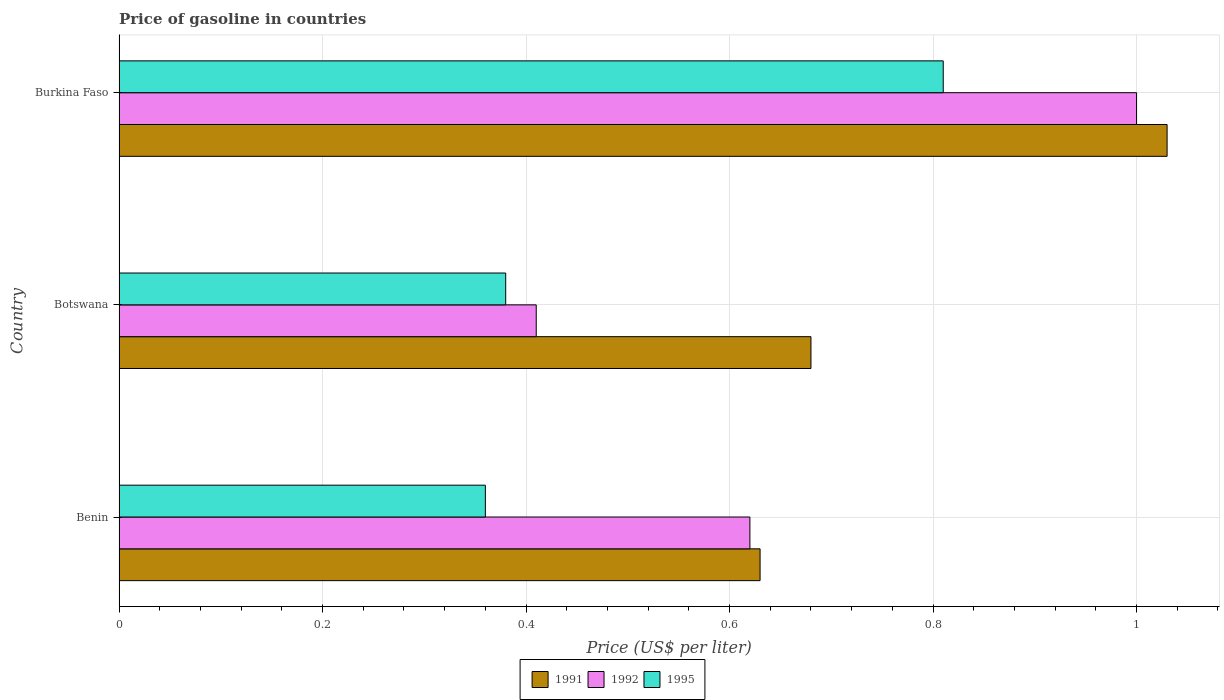How many different coloured bars are there?
Offer a terse response. 3. How many groups of bars are there?
Offer a very short reply. 3. Are the number of bars on each tick of the Y-axis equal?
Your response must be concise. Yes. How many bars are there on the 2nd tick from the bottom?
Offer a very short reply. 3. What is the label of the 1st group of bars from the top?
Provide a succinct answer. Burkina Faso. In how many cases, is the number of bars for a given country not equal to the number of legend labels?
Make the answer very short. 0. What is the price of gasoline in 1992 in Burkina Faso?
Offer a very short reply. 1. Across all countries, what is the maximum price of gasoline in 1995?
Keep it short and to the point. 0.81. Across all countries, what is the minimum price of gasoline in 1995?
Offer a terse response. 0.36. In which country was the price of gasoline in 1995 maximum?
Your answer should be very brief. Burkina Faso. In which country was the price of gasoline in 1991 minimum?
Ensure brevity in your answer.  Benin. What is the total price of gasoline in 1991 in the graph?
Ensure brevity in your answer.  2.34. What is the difference between the price of gasoline in 1992 in Benin and that in Botswana?
Give a very brief answer. 0.21. What is the difference between the price of gasoline in 1991 in Burkina Faso and the price of gasoline in 1992 in Benin?
Give a very brief answer. 0.41. What is the average price of gasoline in 1995 per country?
Provide a short and direct response. 0.52. What is the difference between the price of gasoline in 1991 and price of gasoline in 1992 in Botswana?
Offer a terse response. 0.27. In how many countries, is the price of gasoline in 1991 greater than 0.88 US$?
Your answer should be compact. 1. What is the ratio of the price of gasoline in 1995 in Benin to that in Burkina Faso?
Ensure brevity in your answer.  0.44. Is the price of gasoline in 1995 in Botswana less than that in Burkina Faso?
Offer a very short reply. Yes. What is the difference between the highest and the second highest price of gasoline in 1991?
Provide a succinct answer. 0.35. What is the difference between the highest and the lowest price of gasoline in 1992?
Offer a terse response. 0.59. In how many countries, is the price of gasoline in 1995 greater than the average price of gasoline in 1995 taken over all countries?
Provide a succinct answer. 1. What does the 2nd bar from the top in Benin represents?
Provide a short and direct response. 1992. How many bars are there?
Provide a succinct answer. 9. How many countries are there in the graph?
Your answer should be compact. 3. Does the graph contain any zero values?
Your response must be concise. No. Where does the legend appear in the graph?
Ensure brevity in your answer.  Bottom center. How are the legend labels stacked?
Keep it short and to the point. Horizontal. What is the title of the graph?
Your answer should be very brief. Price of gasoline in countries. Does "2004" appear as one of the legend labels in the graph?
Offer a very short reply. No. What is the label or title of the X-axis?
Offer a terse response. Price (US$ per liter). What is the label or title of the Y-axis?
Offer a very short reply. Country. What is the Price (US$ per liter) of 1991 in Benin?
Provide a short and direct response. 0.63. What is the Price (US$ per liter) of 1992 in Benin?
Offer a terse response. 0.62. What is the Price (US$ per liter) in 1995 in Benin?
Offer a very short reply. 0.36. What is the Price (US$ per liter) in 1991 in Botswana?
Offer a very short reply. 0.68. What is the Price (US$ per liter) of 1992 in Botswana?
Your response must be concise. 0.41. What is the Price (US$ per liter) of 1995 in Botswana?
Keep it short and to the point. 0.38. What is the Price (US$ per liter) in 1991 in Burkina Faso?
Provide a short and direct response. 1.03. What is the Price (US$ per liter) of 1992 in Burkina Faso?
Your response must be concise. 1. What is the Price (US$ per liter) of 1995 in Burkina Faso?
Your response must be concise. 0.81. Across all countries, what is the maximum Price (US$ per liter) in 1991?
Make the answer very short. 1.03. Across all countries, what is the maximum Price (US$ per liter) of 1992?
Your answer should be very brief. 1. Across all countries, what is the maximum Price (US$ per liter) in 1995?
Provide a succinct answer. 0.81. Across all countries, what is the minimum Price (US$ per liter) in 1991?
Provide a short and direct response. 0.63. Across all countries, what is the minimum Price (US$ per liter) in 1992?
Give a very brief answer. 0.41. Across all countries, what is the minimum Price (US$ per liter) of 1995?
Give a very brief answer. 0.36. What is the total Price (US$ per liter) in 1991 in the graph?
Keep it short and to the point. 2.34. What is the total Price (US$ per liter) in 1992 in the graph?
Your answer should be very brief. 2.03. What is the total Price (US$ per liter) of 1995 in the graph?
Your answer should be compact. 1.55. What is the difference between the Price (US$ per liter) of 1991 in Benin and that in Botswana?
Provide a succinct answer. -0.05. What is the difference between the Price (US$ per liter) of 1992 in Benin and that in Botswana?
Your answer should be very brief. 0.21. What is the difference between the Price (US$ per liter) in 1995 in Benin and that in Botswana?
Offer a terse response. -0.02. What is the difference between the Price (US$ per liter) in 1992 in Benin and that in Burkina Faso?
Keep it short and to the point. -0.38. What is the difference between the Price (US$ per liter) of 1995 in Benin and that in Burkina Faso?
Provide a succinct answer. -0.45. What is the difference between the Price (US$ per liter) of 1991 in Botswana and that in Burkina Faso?
Give a very brief answer. -0.35. What is the difference between the Price (US$ per liter) of 1992 in Botswana and that in Burkina Faso?
Your answer should be very brief. -0.59. What is the difference between the Price (US$ per liter) of 1995 in Botswana and that in Burkina Faso?
Your answer should be very brief. -0.43. What is the difference between the Price (US$ per liter) in 1991 in Benin and the Price (US$ per liter) in 1992 in Botswana?
Give a very brief answer. 0.22. What is the difference between the Price (US$ per liter) in 1991 in Benin and the Price (US$ per liter) in 1995 in Botswana?
Ensure brevity in your answer.  0.25. What is the difference between the Price (US$ per liter) in 1992 in Benin and the Price (US$ per liter) in 1995 in Botswana?
Provide a short and direct response. 0.24. What is the difference between the Price (US$ per liter) in 1991 in Benin and the Price (US$ per liter) in 1992 in Burkina Faso?
Offer a very short reply. -0.37. What is the difference between the Price (US$ per liter) in 1991 in Benin and the Price (US$ per liter) in 1995 in Burkina Faso?
Offer a very short reply. -0.18. What is the difference between the Price (US$ per liter) in 1992 in Benin and the Price (US$ per liter) in 1995 in Burkina Faso?
Offer a very short reply. -0.19. What is the difference between the Price (US$ per liter) in 1991 in Botswana and the Price (US$ per liter) in 1992 in Burkina Faso?
Keep it short and to the point. -0.32. What is the difference between the Price (US$ per liter) of 1991 in Botswana and the Price (US$ per liter) of 1995 in Burkina Faso?
Provide a succinct answer. -0.13. What is the difference between the Price (US$ per liter) of 1992 in Botswana and the Price (US$ per liter) of 1995 in Burkina Faso?
Ensure brevity in your answer.  -0.4. What is the average Price (US$ per liter) of 1991 per country?
Give a very brief answer. 0.78. What is the average Price (US$ per liter) of 1992 per country?
Provide a short and direct response. 0.68. What is the average Price (US$ per liter) in 1995 per country?
Provide a short and direct response. 0.52. What is the difference between the Price (US$ per liter) in 1991 and Price (US$ per liter) in 1992 in Benin?
Your answer should be very brief. 0.01. What is the difference between the Price (US$ per liter) in 1991 and Price (US$ per liter) in 1995 in Benin?
Give a very brief answer. 0.27. What is the difference between the Price (US$ per liter) in 1992 and Price (US$ per liter) in 1995 in Benin?
Your answer should be compact. 0.26. What is the difference between the Price (US$ per liter) in 1991 and Price (US$ per liter) in 1992 in Botswana?
Provide a short and direct response. 0.27. What is the difference between the Price (US$ per liter) in 1992 and Price (US$ per liter) in 1995 in Botswana?
Keep it short and to the point. 0.03. What is the difference between the Price (US$ per liter) of 1991 and Price (US$ per liter) of 1992 in Burkina Faso?
Your answer should be compact. 0.03. What is the difference between the Price (US$ per liter) of 1991 and Price (US$ per liter) of 1995 in Burkina Faso?
Ensure brevity in your answer.  0.22. What is the difference between the Price (US$ per liter) in 1992 and Price (US$ per liter) in 1995 in Burkina Faso?
Provide a succinct answer. 0.19. What is the ratio of the Price (US$ per liter) of 1991 in Benin to that in Botswana?
Offer a terse response. 0.93. What is the ratio of the Price (US$ per liter) in 1992 in Benin to that in Botswana?
Keep it short and to the point. 1.51. What is the ratio of the Price (US$ per liter) of 1991 in Benin to that in Burkina Faso?
Offer a very short reply. 0.61. What is the ratio of the Price (US$ per liter) of 1992 in Benin to that in Burkina Faso?
Offer a terse response. 0.62. What is the ratio of the Price (US$ per liter) in 1995 in Benin to that in Burkina Faso?
Give a very brief answer. 0.44. What is the ratio of the Price (US$ per liter) in 1991 in Botswana to that in Burkina Faso?
Offer a very short reply. 0.66. What is the ratio of the Price (US$ per liter) of 1992 in Botswana to that in Burkina Faso?
Provide a succinct answer. 0.41. What is the ratio of the Price (US$ per liter) of 1995 in Botswana to that in Burkina Faso?
Your answer should be compact. 0.47. What is the difference between the highest and the second highest Price (US$ per liter) of 1992?
Offer a very short reply. 0.38. What is the difference between the highest and the second highest Price (US$ per liter) in 1995?
Provide a short and direct response. 0.43. What is the difference between the highest and the lowest Price (US$ per liter) in 1991?
Provide a succinct answer. 0.4. What is the difference between the highest and the lowest Price (US$ per liter) in 1992?
Provide a short and direct response. 0.59. What is the difference between the highest and the lowest Price (US$ per liter) of 1995?
Make the answer very short. 0.45. 